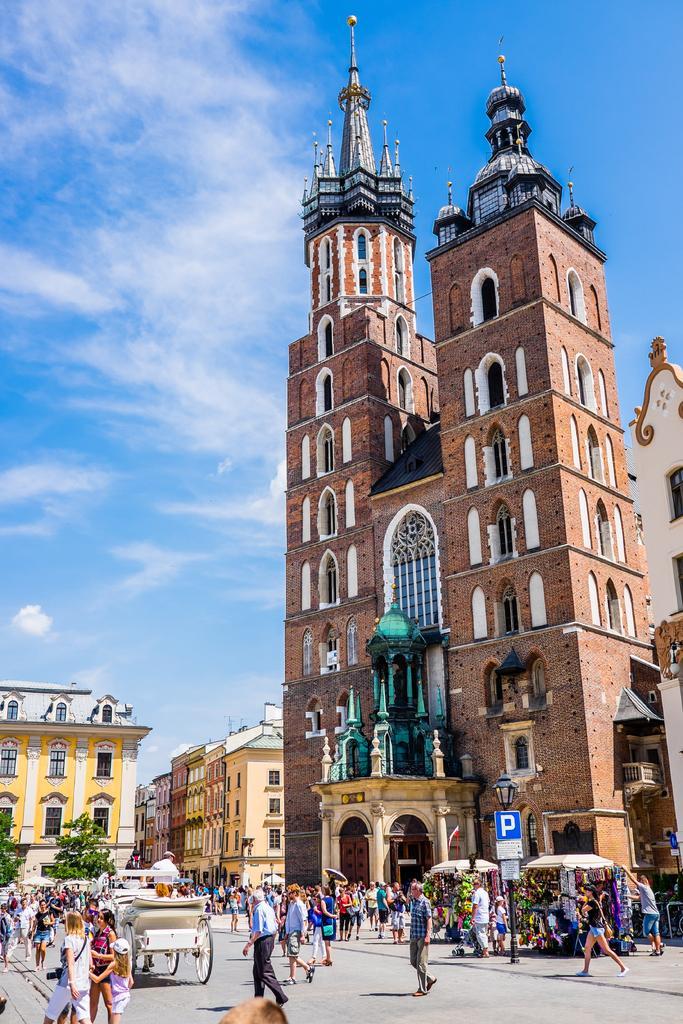In one or two sentences, can you explain what this image depicts? In this picture I can see there are buildings and there are some poles and there are trees. There is crowd here on the road and the sky is clear. 